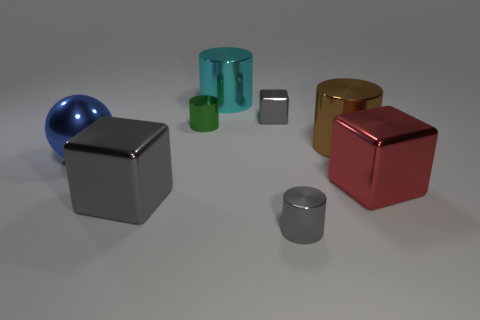There is a small object that is the same color as the small metal block; what material is it?
Provide a short and direct response. Metal. What number of other objects are there of the same material as the big brown cylinder?
Keep it short and to the point. 7. What shape is the metallic thing that is behind the blue sphere and left of the big cyan shiny thing?
Provide a succinct answer. Cylinder. There is a thing that is in front of the big gray object; is its size the same as the gray shiny object to the left of the small green shiny object?
Provide a short and direct response. No. The large blue object that is made of the same material as the big red cube is what shape?
Provide a short and direct response. Sphere. Is there any other thing that has the same shape as the large cyan object?
Your response must be concise. Yes. What color is the thing to the left of the gray block that is in front of the object to the left of the large gray metallic block?
Keep it short and to the point. Blue. Are there fewer tiny shiny cylinders that are behind the green metal object than large blue objects that are in front of the gray cylinder?
Give a very brief answer. No. Is the brown object the same shape as the cyan object?
Make the answer very short. Yes. How many brown shiny things have the same size as the gray cylinder?
Give a very brief answer. 0. 